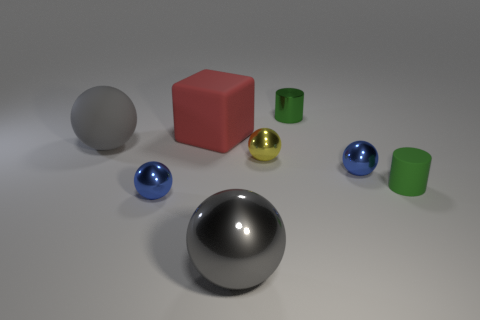Subtract all big matte spheres. How many spheres are left? 4 Subtract 2 spheres. How many spheres are left? 3 Subtract all blue spheres. How many spheres are left? 3 Subtract all purple balls. Subtract all green cubes. How many balls are left? 5 Add 2 matte cylinders. How many objects exist? 10 Subtract all cubes. How many objects are left? 7 Add 7 green objects. How many green objects exist? 9 Subtract 0 red spheres. How many objects are left? 8 Subtract all large things. Subtract all big red things. How many objects are left? 4 Add 1 tiny green things. How many tiny green things are left? 3 